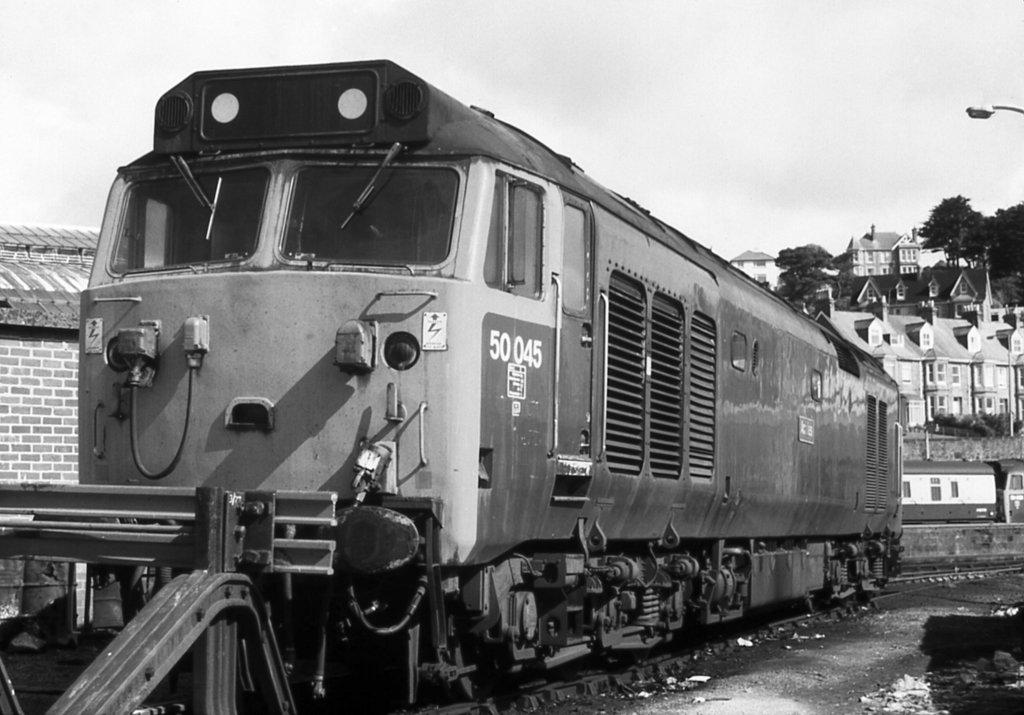What is the color scheme of the image? The image is black and white. What can be seen on the track in the image? There is a train on the track in the image. What is one structure visible in the image? There is a wall visible in the image. What type of vegetation is present in the image? Trees are present in the image. What is the source of light in the image? There is a light source in the image. What type of man-made structures can be seen in the image? There are buildings in the image. What is visible in the background of the image? The sky is visible in the background of the image. How many fowl are sitting on the train in the image? There are no fowl present in the image. --- Facts: 1. There is a person in the image. 2. The person is wearing a hat. 3. The person is holding a book. 4. There is a table in the image. 5. There is a chair in the image. Absurd Topics: unicorn, rainbow, magic wand Conversation: Who or what is in the image? There is a person in the image. What is the person wearing? The person is wearing a hat. What is the person holding? The person is holding a book. What type of furniture is in the image? There is a table and a chair in the image. Reasoning: Let's think step by step in order to produce the conversation. We start by identifying the main subject in the image, which is a person. Then, we describe specific details about the person, such as the hat and the book they are holding. Next, we observe the furniture present in the image, which includes a table and a chair. Each question is designed to elicit a specific detail about the image that is known from the provided facts. Absurd Question/Answer: Where is the unicorn in the image? There is no unicorn present in the image. 